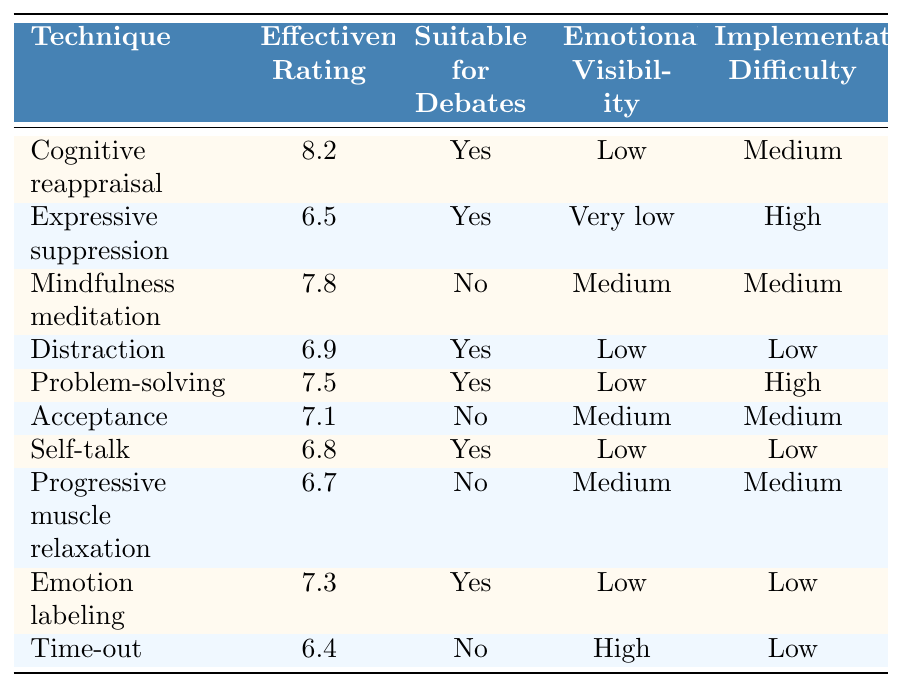What is the effectiveness rating of Cognitive reappraisal? The table lists the effectiveness rating for Cognitive reappraisal as 8.2.
Answer: 8.2 Which technique has the lowest effectiveness rating? By examining the table, we find that the technique with the lowest effectiveness rating is Time-out at 6.4.
Answer: Time-out Is Mindfulness meditation suitable for debates? The table indicates that Mindfulness meditation is not suitable for debates (marked as "No").
Answer: No How many techniques are suitable for debates? Counting the "Yes" responses for suitability in the table, there are 6 techniques that are suitable for debates.
Answer: 6 What is the average effectiveness rating of techniques suitable for debates? The effectiveness ratings for techniques suitable for debates are 8.2, 6.5, 6.9, 7.5, 6.8, and 7.3. The sum is 43.2, and there are 6 techniques, so the average is 43.2 / 6 = 7.2.
Answer: 7.2 Which technique has a medium level of emotional visibility while being suitable for debates? Looking through the table, the only technique that fits this description is Emotion labeling, which has medium emotional visibility and is suitable for debates.
Answer: Emotion labeling What is the implementation difficulty for Expressive suppression? The table states that the implementation difficulty for Expressive suppression is High.
Answer: High Are there any techniques that have a low emotional visibility and high implementation difficulty? The table shows that Problem-solving has low emotional visibility but high implementation difficulty, so there is one such technique.
Answer: Yes What is the difference in effectiveness rating between Cognitive reappraisal and Expressive suppression? The effectiveness rating of Cognitive reappraisal is 8.2 and for Expressive suppression it is 6.5. The difference is 8.2 - 6.5 = 1.7.
Answer: 1.7 Which technique with low emotional visibility also has the highest effectiveness rating? By checking the table, Cognitive reappraisal has low emotional visibility and the highest effectiveness rating of 8.2.
Answer: Cognitive reappraisal 